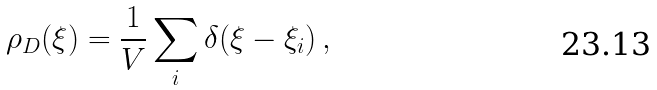<formula> <loc_0><loc_0><loc_500><loc_500>\rho _ { D } ( \xi ) = \frac { 1 } { V } \sum _ { i } \delta ( \xi - \xi _ { i } ) \, ,</formula> 